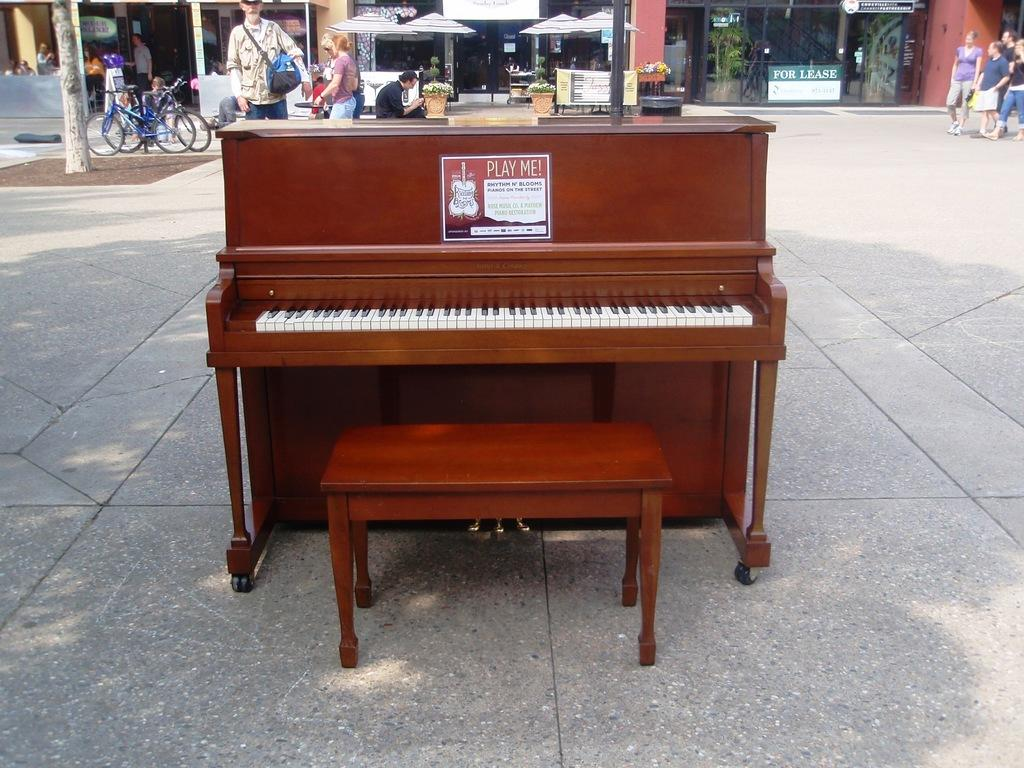What is the main object in the image? There is a piano on the road in the image. What can be seen happening in the background of the image? There is a group of people walking in the background of the image, and there are bicycles visible as well. What type of establishment is present in the background of the image? There is a shop in the background of the image. Is the piano sinking into quicksand in the image? No, there is no quicksand present in the image, and the piano is on the road. What type of corn is being sold in the shop in the image? There is no corn mentioned or visible in the image, as it only shows a piano on the road and a shop in the background. 